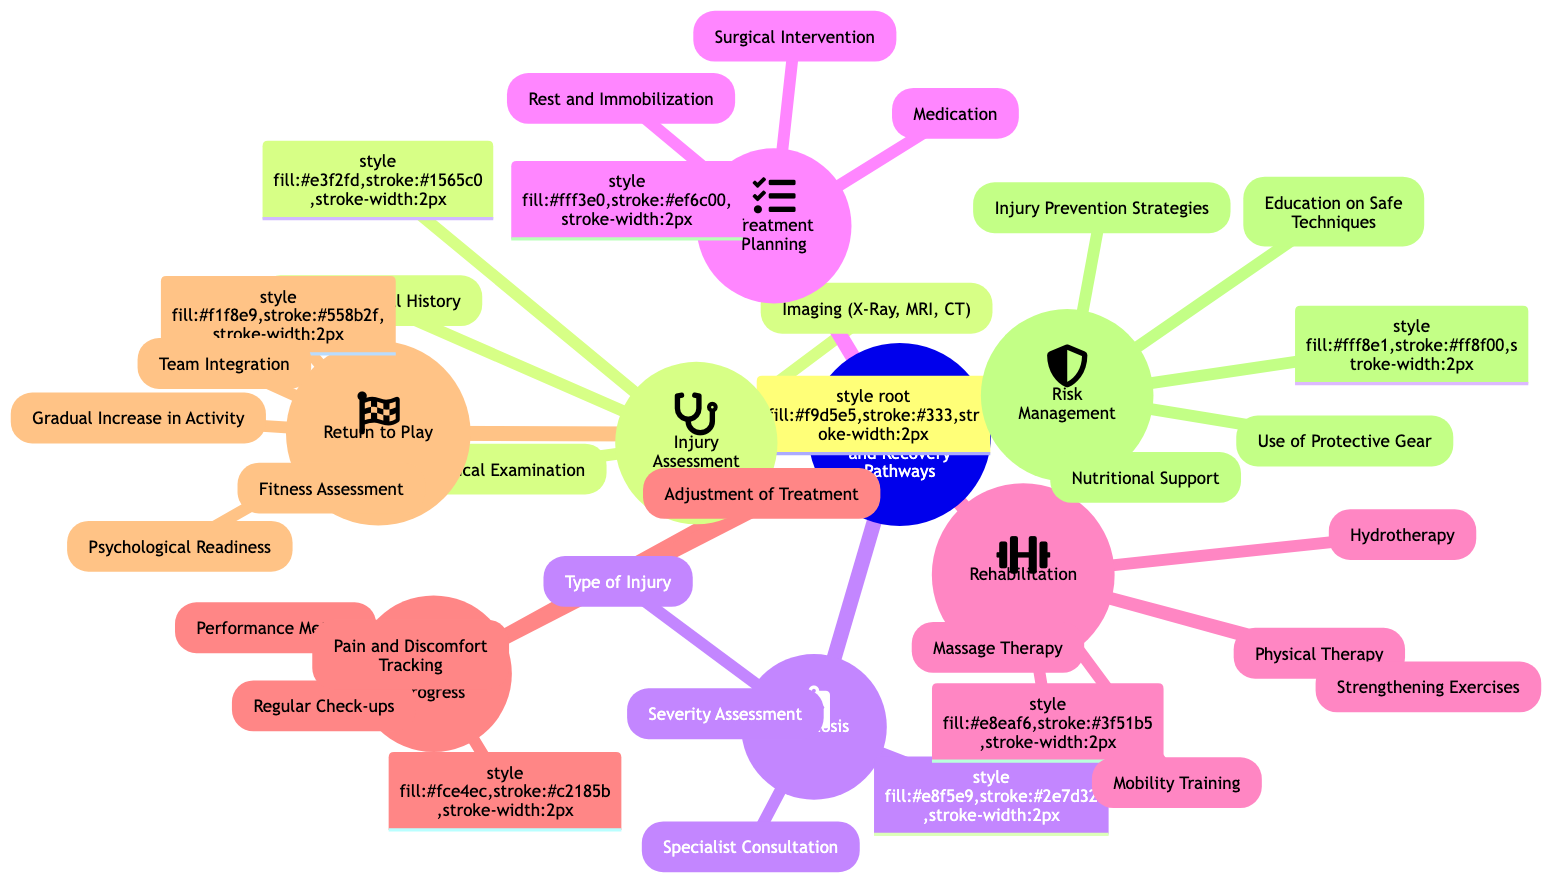What is the central node of the diagram? The central node is labeled as "Rehabilitation and Recovery Pathways," which serves as the primary concept that the other nodes are related to.
Answer: Rehabilitation and Recovery Pathways How many child nodes does "Rehabilitation" have? The node "Rehabilitation" has five child nodes listed underneath it, which can be counted directly from the diagram.
Answer: 5 Name one method involved in "Monitoring Progress". One of the child nodes under "Monitoring Progress" is "Regular Check-ups," which is a method to track the recovery process.
Answer: Regular Check-ups What is the first step in the recovery pathway? The first node in the recovery pathway is "Injury Assessment," indicating that assessing the injury is the initial action.
Answer: Injury Assessment Which node discusses "Injury Prevention Strategies"? "Risk Management" is the parent node that includes "Injury Prevention Strategies" as one of its child nodes.
Answer: Risk Management Which two nodes are directly related to "Return to Play"? The nodes "Fitness Assessment" and "Gradual Increase in Activity" are both child nodes under "Return to Play," indicating important aspects of getting an athlete back into their sport.
Answer: Fitness Assessment, Gradual Increase in Activity How many types of injury are mentioned under "Diagnosis"? The "Diagnosis" node includes three specific types of injuries: "Type of Injury," "Severity Assessment," and "Specialist Consultation," suggesting a focus on these categories in the diagnosis process.
Answer: 3 What is the relationship between "Treatment Planning" and "Surgical Intervention"? "Surgical Intervention" is one of the child nodes under "Treatment Planning," illustrating that it is a part of the overall treatment strategy for injuries when necessary.
Answer: Treatment Planning Which therapy method is associated with "Rehabilitation"? One of the child nodes listed under "Rehabilitation" is "Hydrotherapy," indicating a specific therapeutic method used in recovery.
Answer: Hydrotherapy 